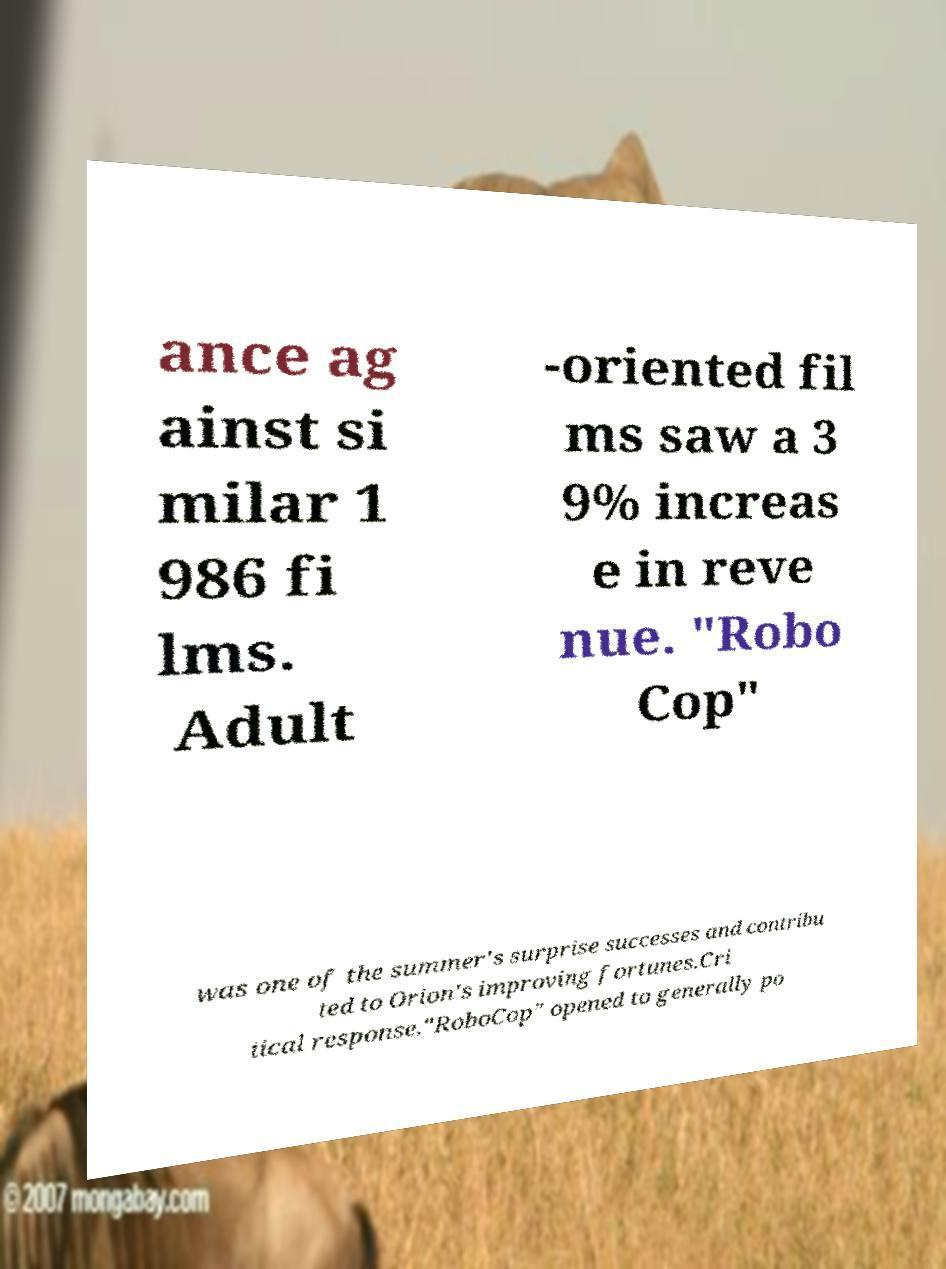Can you read and provide the text displayed in the image?This photo seems to have some interesting text. Can you extract and type it out for me? ance ag ainst si milar 1 986 fi lms. Adult -oriented fil ms saw a 3 9% increas e in reve nue. "Robo Cop" was one of the summer's surprise successes and contribu ted to Orion's improving fortunes.Cri tical response."RoboCop" opened to generally po 